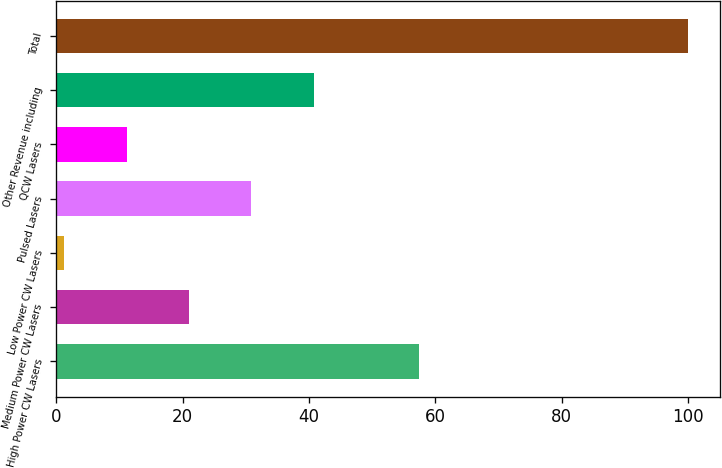<chart> <loc_0><loc_0><loc_500><loc_500><bar_chart><fcel>High Power CW Lasers<fcel>Medium Power CW Lasers<fcel>Low Power CW Lasers<fcel>Pulsed Lasers<fcel>QCW Lasers<fcel>Other Revenue including<fcel>Total<nl><fcel>57.5<fcel>21.04<fcel>1.3<fcel>30.91<fcel>11.17<fcel>40.78<fcel>100<nl></chart> 